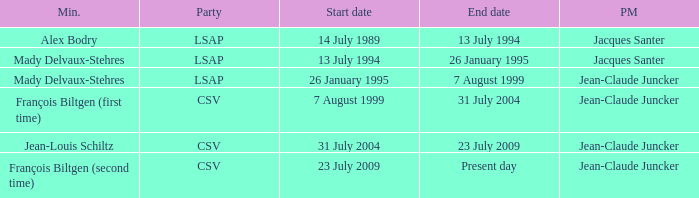Who was the minister for the CSV party with a present day end date? François Biltgen (second time). 